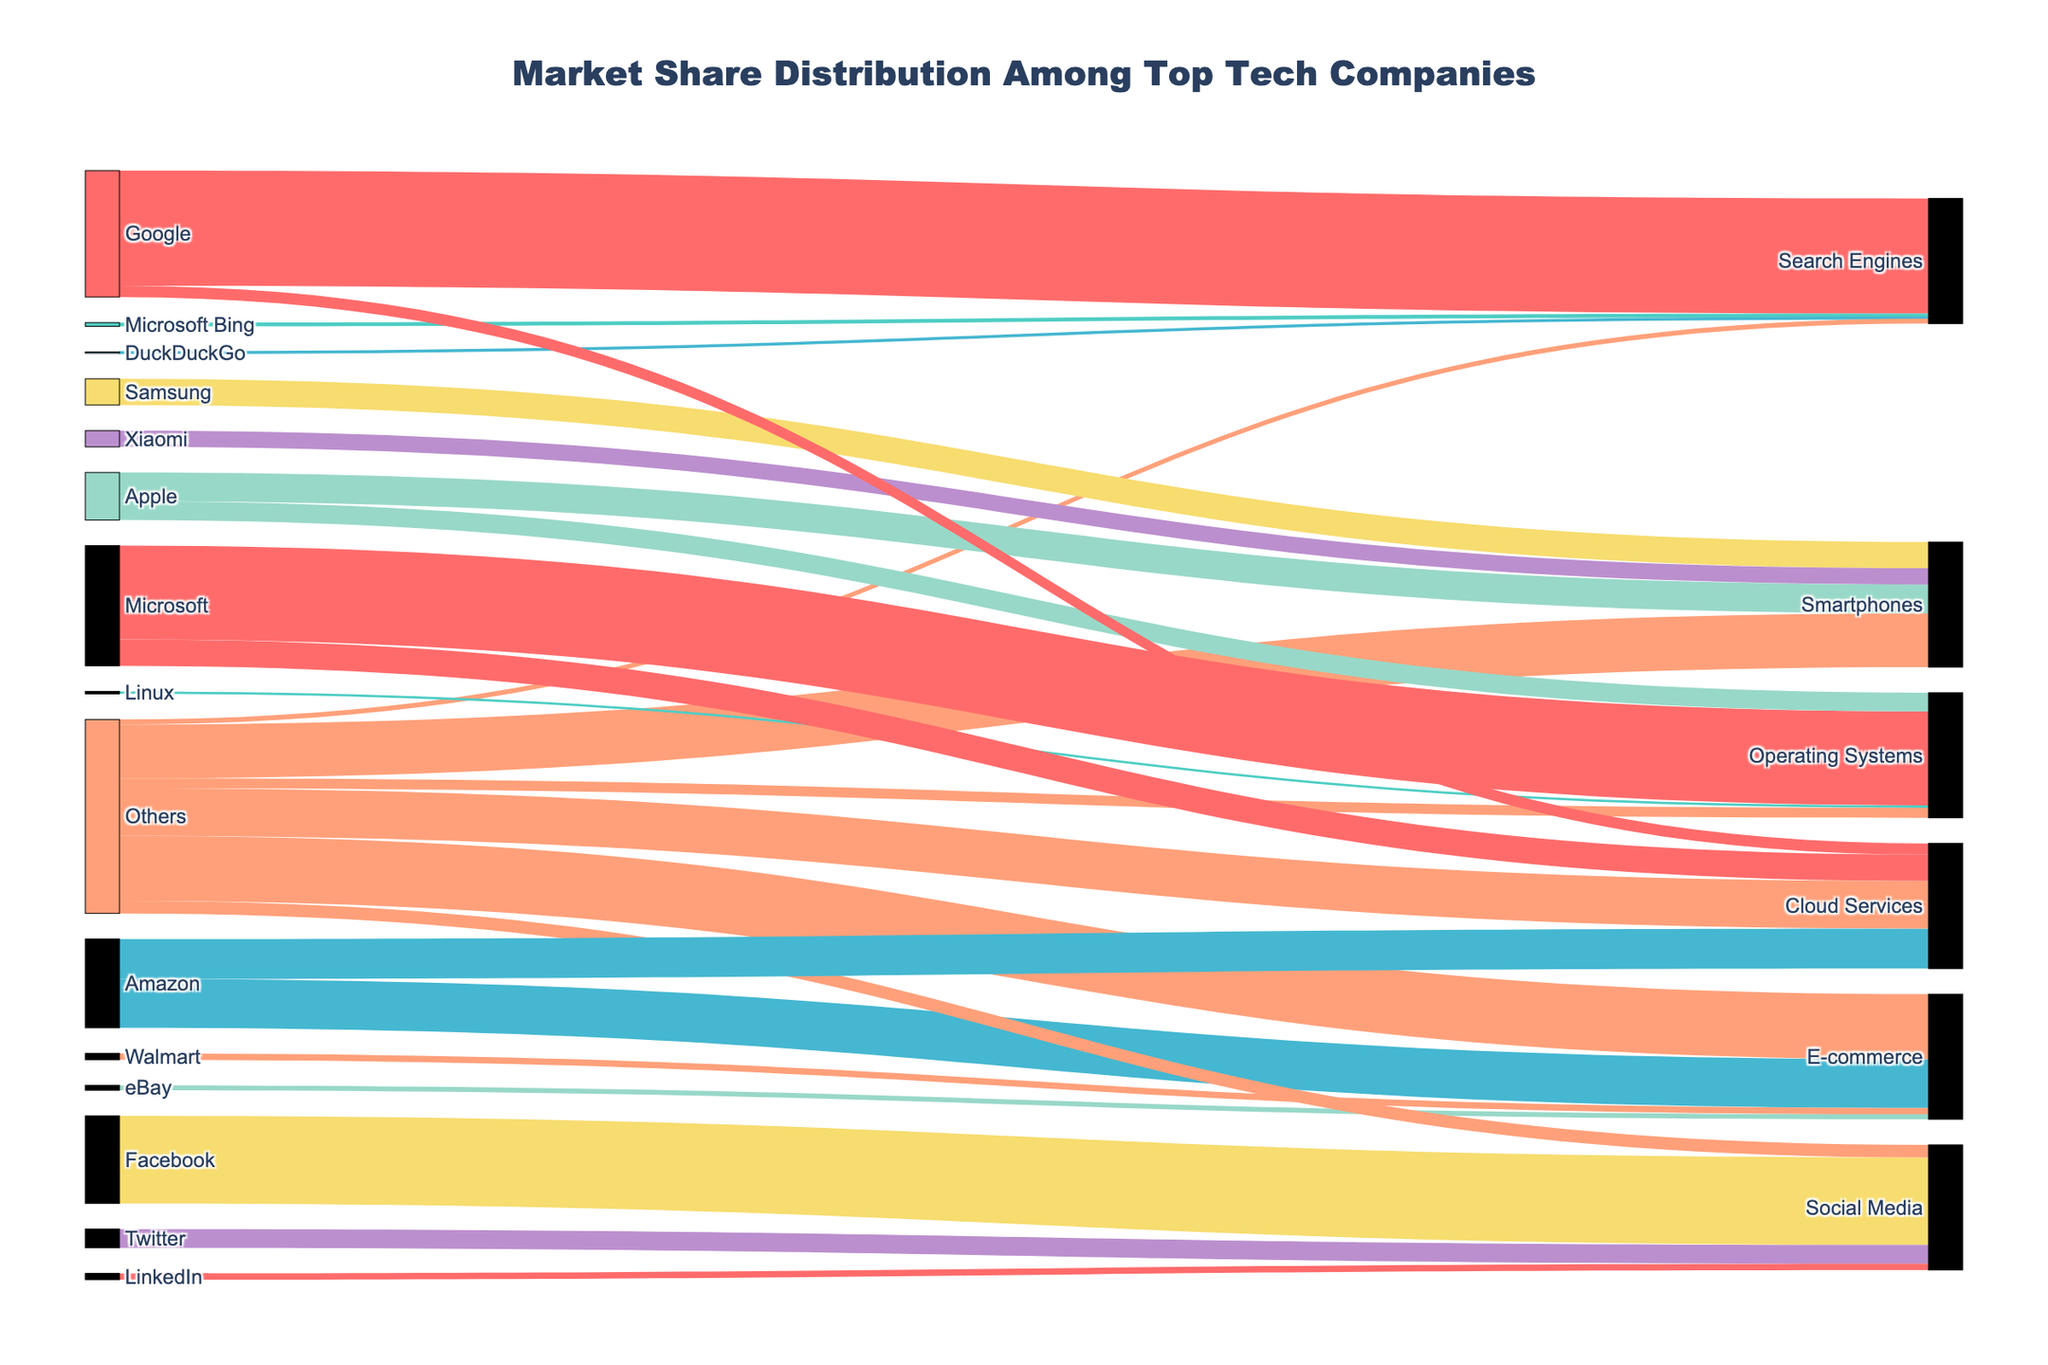What is the title of the figure? The title is usually displayed prominently at the top of the figure. The title of this figure is "Market Share Distribution Among Top Tech Companies."
Answer: Market Share Distribution Among Top Tech Companies Which company has the largest market share in the Search Engines category? The Sankey diagram shows market shares, with Google leading the Search Engines category. Google holds a 92% market share in Search Engines.
Answer: Google How many unique product categories are presented in the diagram? Each target node represents a product category. The product categories are Search Engines, Smartphones, Operating Systems, E-commerce, Social Media, and Cloud Services. There are 6 unique product categories.
Answer: 6 What is the combined market share of Apple and Samsung in the Smartphones category? The values for Apple and Samsung in the Smartphones category are 23% and 21% respectively. Summing these values gives 23 + 21 = 44%.
Answer: 44% How does the market share of Microsoft in Operating Systems compare to its share in Cloud Services? Microsoft has a 75% share in Operating Systems and a 21% share in Cloud Services. Comparing these values, Microsoft's market share in Operating Systems is greater than in Cloud Services.
Answer: Greater in Operating Systems What proportion of the E-commerce market is represented by companies other than Amazon, Walmart, and eBay? The value for "Others" in the E-commerce category represents this proportion. "Others" hold a 52% market share in E-commerce.
Answer: 52% Which company has the second largest market share in Social Media and what is the percentage? The second largest market share in Social Media is held by Twitter with 15%.
Answer: Twitter, 15% Is Google's market share in Cloud Services greater than or less than its market share in Search Engines? Google's market share in Cloud Services is 9%, which is less than its 92% share in Search Engines.
Answer: Less What is the total market share of companies classified as "Others" across all product categories? Summing the "Others" values: Search Engines (4%) + Smartphones (43%) + Operating Systems (8%) + E-commerce (52%) + Social Media (10%) + Cloud Services (38%) = 155%.
Answer: 155% How many companies are depicted in the E-commerce category? Each source node linked to the E-commerce target node represents a company. There are four companies: Amazon, Walmart, eBay, and Others.
Answer: 4 